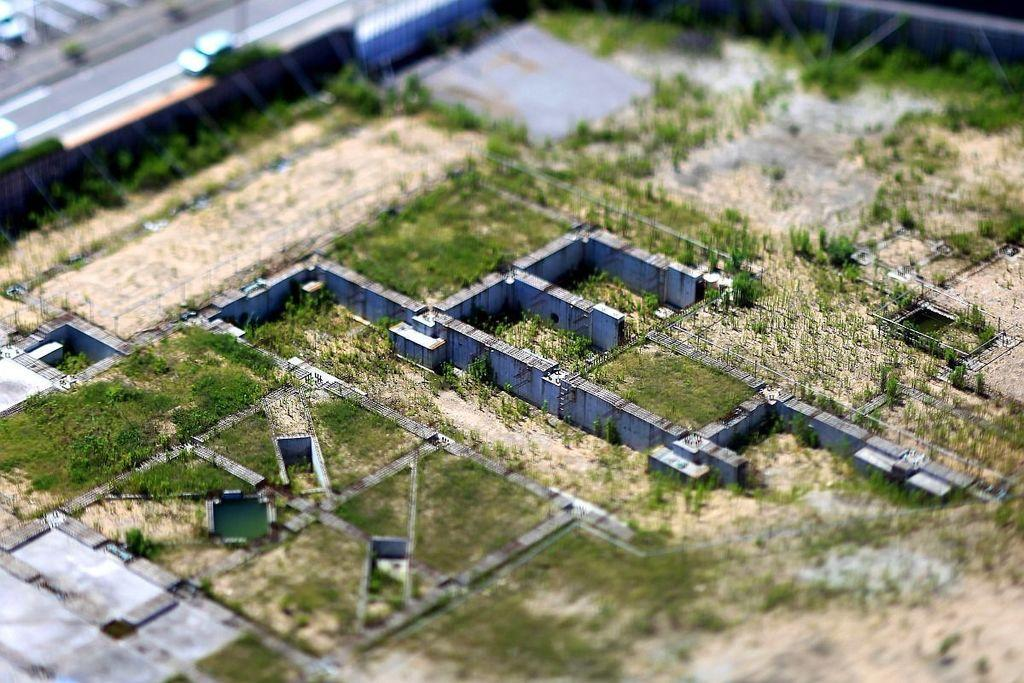What type of surface is visible in the image? There is ground visible in the image. What type of vegetation is present on the ground? There is grass on the ground. What type of structures are present on the ground? There are walls visible in the image. What type of pathway is visible in the image? There is a road visible in the image. What type of objects are present on the road? There are vehicles on the road. How many chairs are placed around the board in the image? There are no chairs or boards present in the image. Can you describe the behavior of the geese in the image? There are no geese present in the image. 